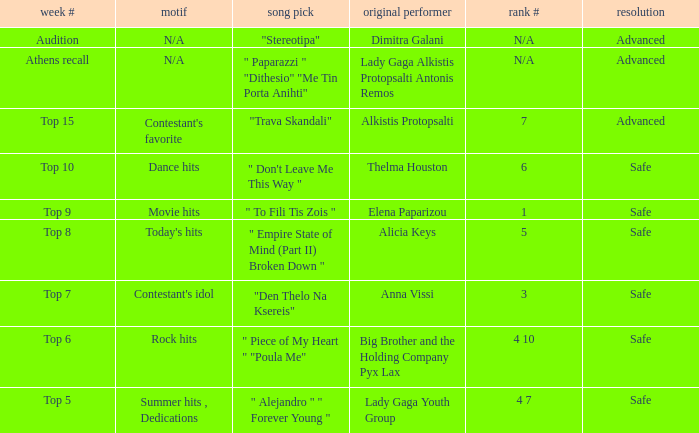Which artists have order # 1? Elena Paparizou. 